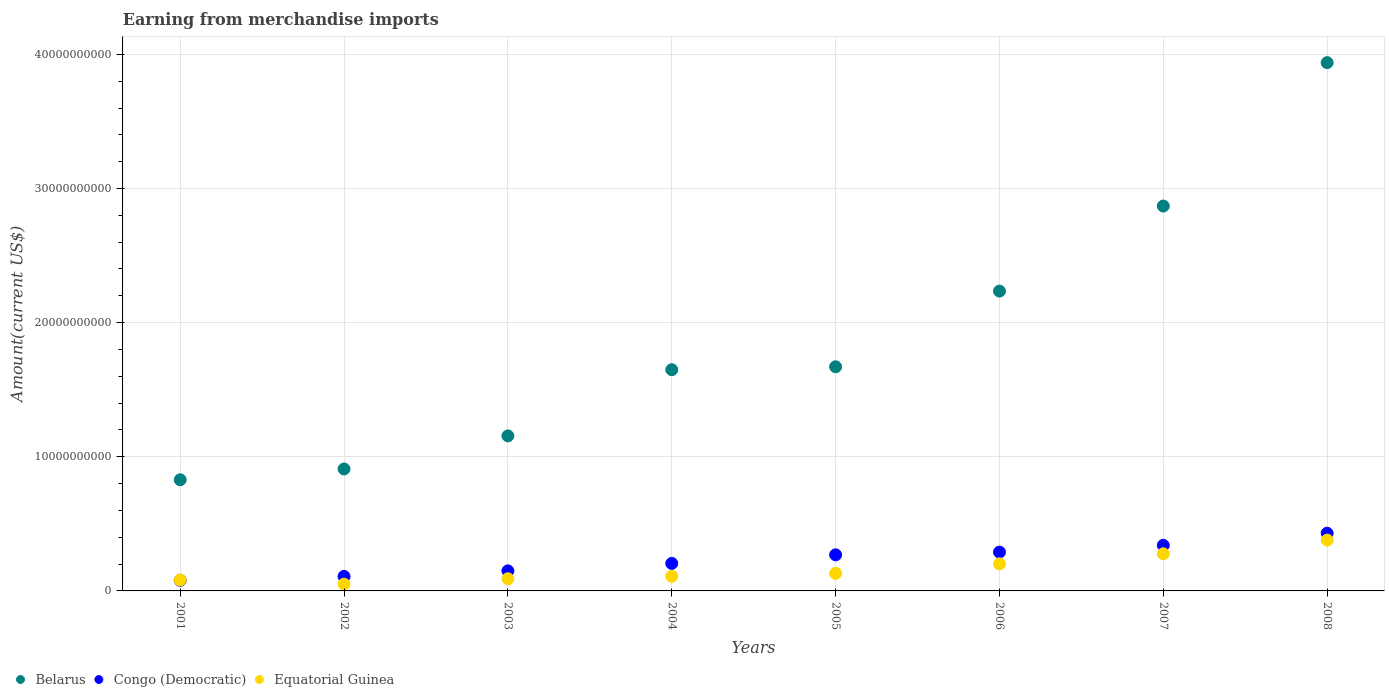What is the amount earned from merchandise imports in Congo (Democratic) in 2007?
Ensure brevity in your answer.  3.40e+09. Across all years, what is the maximum amount earned from merchandise imports in Equatorial Guinea?
Your answer should be compact. 3.79e+09. Across all years, what is the minimum amount earned from merchandise imports in Belarus?
Provide a short and direct response. 8.29e+09. In which year was the amount earned from merchandise imports in Equatorial Guinea minimum?
Your answer should be compact. 2002. What is the total amount earned from merchandise imports in Equatorial Guinea in the graph?
Provide a short and direct response. 1.32e+1. What is the difference between the amount earned from merchandise imports in Equatorial Guinea in 2001 and that in 2006?
Provide a short and direct response. -1.21e+09. What is the difference between the amount earned from merchandise imports in Congo (Democratic) in 2006 and the amount earned from merchandise imports in Equatorial Guinea in 2005?
Offer a very short reply. 1.58e+09. What is the average amount earned from merchandise imports in Belarus per year?
Your answer should be compact. 1.91e+1. In the year 2005, what is the difference between the amount earned from merchandise imports in Congo (Democratic) and amount earned from merchandise imports in Equatorial Guinea?
Provide a short and direct response. 1.38e+09. What is the ratio of the amount earned from merchandise imports in Belarus in 2001 to that in 2005?
Make the answer very short. 0.5. Is the difference between the amount earned from merchandise imports in Congo (Democratic) in 2004 and 2007 greater than the difference between the amount earned from merchandise imports in Equatorial Guinea in 2004 and 2007?
Make the answer very short. Yes. What is the difference between the highest and the second highest amount earned from merchandise imports in Belarus?
Ensure brevity in your answer.  1.07e+1. What is the difference between the highest and the lowest amount earned from merchandise imports in Congo (Democratic)?
Your answer should be very brief. 3.51e+09. In how many years, is the amount earned from merchandise imports in Congo (Democratic) greater than the average amount earned from merchandise imports in Congo (Democratic) taken over all years?
Provide a short and direct response. 4. Is the amount earned from merchandise imports in Belarus strictly less than the amount earned from merchandise imports in Equatorial Guinea over the years?
Give a very brief answer. No. What is the difference between two consecutive major ticks on the Y-axis?
Provide a short and direct response. 1.00e+1. Where does the legend appear in the graph?
Your response must be concise. Bottom left. How many legend labels are there?
Give a very brief answer. 3. How are the legend labels stacked?
Provide a succinct answer. Horizontal. What is the title of the graph?
Offer a terse response. Earning from merchandise imports. What is the label or title of the Y-axis?
Your response must be concise. Amount(current US$). What is the Amount(current US$) of Belarus in 2001?
Your response must be concise. 8.29e+09. What is the Amount(current US$) in Congo (Democratic) in 2001?
Your response must be concise. 7.90e+08. What is the Amount(current US$) of Equatorial Guinea in 2001?
Give a very brief answer. 8.13e+08. What is the Amount(current US$) in Belarus in 2002?
Provide a short and direct response. 9.09e+09. What is the Amount(current US$) of Congo (Democratic) in 2002?
Your answer should be very brief. 1.08e+09. What is the Amount(current US$) in Equatorial Guinea in 2002?
Give a very brief answer. 5.07e+08. What is the Amount(current US$) in Belarus in 2003?
Your answer should be compact. 1.16e+1. What is the Amount(current US$) of Congo (Democratic) in 2003?
Your response must be concise. 1.49e+09. What is the Amount(current US$) in Equatorial Guinea in 2003?
Provide a short and direct response. 9.08e+08. What is the Amount(current US$) of Belarus in 2004?
Ensure brevity in your answer.  1.65e+1. What is the Amount(current US$) of Congo (Democratic) in 2004?
Provide a succinct answer. 2.05e+09. What is the Amount(current US$) in Equatorial Guinea in 2004?
Ensure brevity in your answer.  1.09e+09. What is the Amount(current US$) of Belarus in 2005?
Offer a very short reply. 1.67e+1. What is the Amount(current US$) in Congo (Democratic) in 2005?
Your response must be concise. 2.69e+09. What is the Amount(current US$) in Equatorial Guinea in 2005?
Provide a short and direct response. 1.31e+09. What is the Amount(current US$) in Belarus in 2006?
Your response must be concise. 2.24e+1. What is the Amount(current US$) of Congo (Democratic) in 2006?
Provide a succinct answer. 2.89e+09. What is the Amount(current US$) in Equatorial Guinea in 2006?
Your answer should be compact. 2.02e+09. What is the Amount(current US$) of Belarus in 2007?
Provide a short and direct response. 2.87e+1. What is the Amount(current US$) in Congo (Democratic) in 2007?
Your answer should be very brief. 3.40e+09. What is the Amount(current US$) in Equatorial Guinea in 2007?
Offer a terse response. 2.77e+09. What is the Amount(current US$) of Belarus in 2008?
Provide a short and direct response. 3.94e+1. What is the Amount(current US$) of Congo (Democratic) in 2008?
Provide a succinct answer. 4.30e+09. What is the Amount(current US$) of Equatorial Guinea in 2008?
Ensure brevity in your answer.  3.79e+09. Across all years, what is the maximum Amount(current US$) of Belarus?
Make the answer very short. 3.94e+1. Across all years, what is the maximum Amount(current US$) in Congo (Democratic)?
Keep it short and to the point. 4.30e+09. Across all years, what is the maximum Amount(current US$) of Equatorial Guinea?
Your answer should be compact. 3.79e+09. Across all years, what is the minimum Amount(current US$) of Belarus?
Give a very brief answer. 8.29e+09. Across all years, what is the minimum Amount(current US$) in Congo (Democratic)?
Provide a succinct answer. 7.90e+08. Across all years, what is the minimum Amount(current US$) of Equatorial Guinea?
Give a very brief answer. 5.07e+08. What is the total Amount(current US$) of Belarus in the graph?
Your answer should be compact. 1.53e+11. What is the total Amount(current US$) of Congo (Democratic) in the graph?
Offer a very short reply. 1.87e+1. What is the total Amount(current US$) of Equatorial Guinea in the graph?
Offer a terse response. 1.32e+1. What is the difference between the Amount(current US$) of Belarus in 2001 and that in 2002?
Provide a succinct answer. -8.06e+08. What is the difference between the Amount(current US$) in Congo (Democratic) in 2001 and that in 2002?
Provide a succinct answer. -2.91e+08. What is the difference between the Amount(current US$) in Equatorial Guinea in 2001 and that in 2002?
Provide a short and direct response. 3.06e+08. What is the difference between the Amount(current US$) in Belarus in 2001 and that in 2003?
Make the answer very short. -3.27e+09. What is the difference between the Amount(current US$) in Congo (Democratic) in 2001 and that in 2003?
Provide a short and direct response. -7.05e+08. What is the difference between the Amount(current US$) of Equatorial Guinea in 2001 and that in 2003?
Provide a short and direct response. -9.50e+07. What is the difference between the Amount(current US$) of Belarus in 2001 and that in 2004?
Make the answer very short. -8.20e+09. What is the difference between the Amount(current US$) in Congo (Democratic) in 2001 and that in 2004?
Your response must be concise. -1.26e+09. What is the difference between the Amount(current US$) of Equatorial Guinea in 2001 and that in 2004?
Make the answer very short. -2.79e+08. What is the difference between the Amount(current US$) in Belarus in 2001 and that in 2005?
Offer a very short reply. -8.42e+09. What is the difference between the Amount(current US$) of Congo (Democratic) in 2001 and that in 2005?
Offer a very short reply. -1.90e+09. What is the difference between the Amount(current US$) in Equatorial Guinea in 2001 and that in 2005?
Provide a succinct answer. -4.97e+08. What is the difference between the Amount(current US$) in Belarus in 2001 and that in 2006?
Offer a very short reply. -1.41e+1. What is the difference between the Amount(current US$) in Congo (Democratic) in 2001 and that in 2006?
Your answer should be compact. -2.10e+09. What is the difference between the Amount(current US$) in Equatorial Guinea in 2001 and that in 2006?
Offer a very short reply. -1.21e+09. What is the difference between the Amount(current US$) of Belarus in 2001 and that in 2007?
Give a very brief answer. -2.04e+1. What is the difference between the Amount(current US$) in Congo (Democratic) in 2001 and that in 2007?
Provide a short and direct response. -2.61e+09. What is the difference between the Amount(current US$) in Equatorial Guinea in 2001 and that in 2007?
Offer a very short reply. -1.95e+09. What is the difference between the Amount(current US$) in Belarus in 2001 and that in 2008?
Keep it short and to the point. -3.11e+1. What is the difference between the Amount(current US$) in Congo (Democratic) in 2001 and that in 2008?
Your answer should be compact. -3.51e+09. What is the difference between the Amount(current US$) of Equatorial Guinea in 2001 and that in 2008?
Make the answer very short. -2.97e+09. What is the difference between the Amount(current US$) in Belarus in 2002 and that in 2003?
Provide a succinct answer. -2.47e+09. What is the difference between the Amount(current US$) in Congo (Democratic) in 2002 and that in 2003?
Provide a succinct answer. -4.14e+08. What is the difference between the Amount(current US$) in Equatorial Guinea in 2002 and that in 2003?
Make the answer very short. -4.01e+08. What is the difference between the Amount(current US$) in Belarus in 2002 and that in 2004?
Offer a very short reply. -7.40e+09. What is the difference between the Amount(current US$) in Congo (Democratic) in 2002 and that in 2004?
Ensure brevity in your answer.  -9.71e+08. What is the difference between the Amount(current US$) in Equatorial Guinea in 2002 and that in 2004?
Your answer should be very brief. -5.85e+08. What is the difference between the Amount(current US$) of Belarus in 2002 and that in 2005?
Your answer should be compact. -7.62e+09. What is the difference between the Amount(current US$) in Congo (Democratic) in 2002 and that in 2005?
Make the answer very short. -1.61e+09. What is the difference between the Amount(current US$) in Equatorial Guinea in 2002 and that in 2005?
Your answer should be compact. -8.03e+08. What is the difference between the Amount(current US$) in Belarus in 2002 and that in 2006?
Ensure brevity in your answer.  -1.33e+1. What is the difference between the Amount(current US$) of Congo (Democratic) in 2002 and that in 2006?
Your response must be concise. -1.81e+09. What is the difference between the Amount(current US$) of Equatorial Guinea in 2002 and that in 2006?
Your response must be concise. -1.51e+09. What is the difference between the Amount(current US$) in Belarus in 2002 and that in 2007?
Ensure brevity in your answer.  -1.96e+1. What is the difference between the Amount(current US$) of Congo (Democratic) in 2002 and that in 2007?
Make the answer very short. -2.32e+09. What is the difference between the Amount(current US$) in Equatorial Guinea in 2002 and that in 2007?
Give a very brief answer. -2.26e+09. What is the difference between the Amount(current US$) of Belarus in 2002 and that in 2008?
Your answer should be very brief. -3.03e+1. What is the difference between the Amount(current US$) of Congo (Democratic) in 2002 and that in 2008?
Ensure brevity in your answer.  -3.22e+09. What is the difference between the Amount(current US$) in Equatorial Guinea in 2002 and that in 2008?
Your answer should be very brief. -3.28e+09. What is the difference between the Amount(current US$) of Belarus in 2003 and that in 2004?
Offer a very short reply. -4.93e+09. What is the difference between the Amount(current US$) in Congo (Democratic) in 2003 and that in 2004?
Make the answer very short. -5.57e+08. What is the difference between the Amount(current US$) in Equatorial Guinea in 2003 and that in 2004?
Give a very brief answer. -1.84e+08. What is the difference between the Amount(current US$) of Belarus in 2003 and that in 2005?
Make the answer very short. -5.15e+09. What is the difference between the Amount(current US$) in Congo (Democratic) in 2003 and that in 2005?
Give a very brief answer. -1.20e+09. What is the difference between the Amount(current US$) in Equatorial Guinea in 2003 and that in 2005?
Ensure brevity in your answer.  -4.02e+08. What is the difference between the Amount(current US$) of Belarus in 2003 and that in 2006?
Offer a terse response. -1.08e+1. What is the difference between the Amount(current US$) of Congo (Democratic) in 2003 and that in 2006?
Make the answer very short. -1.40e+09. What is the difference between the Amount(current US$) in Equatorial Guinea in 2003 and that in 2006?
Offer a very short reply. -1.11e+09. What is the difference between the Amount(current US$) of Belarus in 2003 and that in 2007?
Keep it short and to the point. -1.71e+1. What is the difference between the Amount(current US$) of Congo (Democratic) in 2003 and that in 2007?
Your answer should be compact. -1.91e+09. What is the difference between the Amount(current US$) in Equatorial Guinea in 2003 and that in 2007?
Make the answer very short. -1.86e+09. What is the difference between the Amount(current US$) of Belarus in 2003 and that in 2008?
Your answer should be very brief. -2.78e+1. What is the difference between the Amount(current US$) in Congo (Democratic) in 2003 and that in 2008?
Ensure brevity in your answer.  -2.81e+09. What is the difference between the Amount(current US$) in Equatorial Guinea in 2003 and that in 2008?
Your response must be concise. -2.88e+09. What is the difference between the Amount(current US$) of Belarus in 2004 and that in 2005?
Make the answer very short. -2.17e+08. What is the difference between the Amount(current US$) of Congo (Democratic) in 2004 and that in 2005?
Your answer should be very brief. -6.39e+08. What is the difference between the Amount(current US$) in Equatorial Guinea in 2004 and that in 2005?
Your answer should be compact. -2.18e+08. What is the difference between the Amount(current US$) in Belarus in 2004 and that in 2006?
Provide a short and direct response. -5.86e+09. What is the difference between the Amount(current US$) of Congo (Democratic) in 2004 and that in 2006?
Keep it short and to the point. -8.40e+08. What is the difference between the Amount(current US$) in Equatorial Guinea in 2004 and that in 2006?
Provide a short and direct response. -9.28e+08. What is the difference between the Amount(current US$) of Belarus in 2004 and that in 2007?
Make the answer very short. -1.22e+1. What is the difference between the Amount(current US$) in Congo (Democratic) in 2004 and that in 2007?
Keep it short and to the point. -1.35e+09. What is the difference between the Amount(current US$) of Equatorial Guinea in 2004 and that in 2007?
Your response must be concise. -1.68e+09. What is the difference between the Amount(current US$) of Belarus in 2004 and that in 2008?
Keep it short and to the point. -2.29e+1. What is the difference between the Amount(current US$) of Congo (Democratic) in 2004 and that in 2008?
Provide a short and direct response. -2.25e+09. What is the difference between the Amount(current US$) in Equatorial Guinea in 2004 and that in 2008?
Make the answer very short. -2.69e+09. What is the difference between the Amount(current US$) in Belarus in 2005 and that in 2006?
Provide a short and direct response. -5.64e+09. What is the difference between the Amount(current US$) of Congo (Democratic) in 2005 and that in 2006?
Your response must be concise. -2.01e+08. What is the difference between the Amount(current US$) in Equatorial Guinea in 2005 and that in 2006?
Your answer should be very brief. -7.10e+08. What is the difference between the Amount(current US$) in Belarus in 2005 and that in 2007?
Give a very brief answer. -1.20e+1. What is the difference between the Amount(current US$) of Congo (Democratic) in 2005 and that in 2007?
Keep it short and to the point. -7.10e+08. What is the difference between the Amount(current US$) of Equatorial Guinea in 2005 and that in 2007?
Your response must be concise. -1.46e+09. What is the difference between the Amount(current US$) of Belarus in 2005 and that in 2008?
Offer a terse response. -2.27e+1. What is the difference between the Amount(current US$) of Congo (Democratic) in 2005 and that in 2008?
Keep it short and to the point. -1.61e+09. What is the difference between the Amount(current US$) of Equatorial Guinea in 2005 and that in 2008?
Offer a very short reply. -2.48e+09. What is the difference between the Amount(current US$) in Belarus in 2006 and that in 2007?
Provide a succinct answer. -6.34e+09. What is the difference between the Amount(current US$) of Congo (Democratic) in 2006 and that in 2007?
Provide a short and direct response. -5.08e+08. What is the difference between the Amount(current US$) in Equatorial Guinea in 2006 and that in 2007?
Provide a short and direct response. -7.47e+08. What is the difference between the Amount(current US$) in Belarus in 2006 and that in 2008?
Offer a very short reply. -1.70e+1. What is the difference between the Amount(current US$) of Congo (Democratic) in 2006 and that in 2008?
Give a very brief answer. -1.41e+09. What is the difference between the Amount(current US$) in Equatorial Guinea in 2006 and that in 2008?
Provide a succinct answer. -1.77e+09. What is the difference between the Amount(current US$) in Belarus in 2007 and that in 2008?
Provide a short and direct response. -1.07e+1. What is the difference between the Amount(current US$) in Congo (Democratic) in 2007 and that in 2008?
Provide a short and direct response. -9.00e+08. What is the difference between the Amount(current US$) in Equatorial Guinea in 2007 and that in 2008?
Your answer should be compact. -1.02e+09. What is the difference between the Amount(current US$) of Belarus in 2001 and the Amount(current US$) of Congo (Democratic) in 2002?
Your answer should be very brief. 7.21e+09. What is the difference between the Amount(current US$) in Belarus in 2001 and the Amount(current US$) in Equatorial Guinea in 2002?
Ensure brevity in your answer.  7.78e+09. What is the difference between the Amount(current US$) in Congo (Democratic) in 2001 and the Amount(current US$) in Equatorial Guinea in 2002?
Your response must be concise. 2.82e+08. What is the difference between the Amount(current US$) in Belarus in 2001 and the Amount(current US$) in Congo (Democratic) in 2003?
Make the answer very short. 6.79e+09. What is the difference between the Amount(current US$) of Belarus in 2001 and the Amount(current US$) of Equatorial Guinea in 2003?
Your response must be concise. 7.38e+09. What is the difference between the Amount(current US$) in Congo (Democratic) in 2001 and the Amount(current US$) in Equatorial Guinea in 2003?
Offer a very short reply. -1.18e+08. What is the difference between the Amount(current US$) in Belarus in 2001 and the Amount(current US$) in Congo (Democratic) in 2004?
Offer a terse response. 6.23e+09. What is the difference between the Amount(current US$) in Belarus in 2001 and the Amount(current US$) in Equatorial Guinea in 2004?
Ensure brevity in your answer.  7.19e+09. What is the difference between the Amount(current US$) in Congo (Democratic) in 2001 and the Amount(current US$) in Equatorial Guinea in 2004?
Your answer should be very brief. -3.02e+08. What is the difference between the Amount(current US$) of Belarus in 2001 and the Amount(current US$) of Congo (Democratic) in 2005?
Offer a very short reply. 5.60e+09. What is the difference between the Amount(current US$) in Belarus in 2001 and the Amount(current US$) in Equatorial Guinea in 2005?
Your response must be concise. 6.98e+09. What is the difference between the Amount(current US$) of Congo (Democratic) in 2001 and the Amount(current US$) of Equatorial Guinea in 2005?
Provide a succinct answer. -5.20e+08. What is the difference between the Amount(current US$) in Belarus in 2001 and the Amount(current US$) in Congo (Democratic) in 2006?
Provide a succinct answer. 5.39e+09. What is the difference between the Amount(current US$) of Belarus in 2001 and the Amount(current US$) of Equatorial Guinea in 2006?
Offer a very short reply. 6.27e+09. What is the difference between the Amount(current US$) of Congo (Democratic) in 2001 and the Amount(current US$) of Equatorial Guinea in 2006?
Provide a short and direct response. -1.23e+09. What is the difference between the Amount(current US$) of Belarus in 2001 and the Amount(current US$) of Congo (Democratic) in 2007?
Make the answer very short. 4.89e+09. What is the difference between the Amount(current US$) of Belarus in 2001 and the Amount(current US$) of Equatorial Guinea in 2007?
Your answer should be very brief. 5.52e+09. What is the difference between the Amount(current US$) in Congo (Democratic) in 2001 and the Amount(current US$) in Equatorial Guinea in 2007?
Your answer should be very brief. -1.98e+09. What is the difference between the Amount(current US$) of Belarus in 2001 and the Amount(current US$) of Congo (Democratic) in 2008?
Offer a terse response. 3.99e+09. What is the difference between the Amount(current US$) of Belarus in 2001 and the Amount(current US$) of Equatorial Guinea in 2008?
Provide a short and direct response. 4.50e+09. What is the difference between the Amount(current US$) of Congo (Democratic) in 2001 and the Amount(current US$) of Equatorial Guinea in 2008?
Ensure brevity in your answer.  -3.00e+09. What is the difference between the Amount(current US$) of Belarus in 2002 and the Amount(current US$) of Congo (Democratic) in 2003?
Your answer should be compact. 7.60e+09. What is the difference between the Amount(current US$) in Belarus in 2002 and the Amount(current US$) in Equatorial Guinea in 2003?
Provide a succinct answer. 8.18e+09. What is the difference between the Amount(current US$) of Congo (Democratic) in 2002 and the Amount(current US$) of Equatorial Guinea in 2003?
Offer a terse response. 1.72e+08. What is the difference between the Amount(current US$) in Belarus in 2002 and the Amount(current US$) in Congo (Democratic) in 2004?
Give a very brief answer. 7.04e+09. What is the difference between the Amount(current US$) of Belarus in 2002 and the Amount(current US$) of Equatorial Guinea in 2004?
Your answer should be compact. 8.00e+09. What is the difference between the Amount(current US$) in Congo (Democratic) in 2002 and the Amount(current US$) in Equatorial Guinea in 2004?
Provide a succinct answer. -1.15e+07. What is the difference between the Amount(current US$) in Belarus in 2002 and the Amount(current US$) in Congo (Democratic) in 2005?
Offer a terse response. 6.40e+09. What is the difference between the Amount(current US$) in Belarus in 2002 and the Amount(current US$) in Equatorial Guinea in 2005?
Make the answer very short. 7.78e+09. What is the difference between the Amount(current US$) of Congo (Democratic) in 2002 and the Amount(current US$) of Equatorial Guinea in 2005?
Make the answer very short. -2.30e+08. What is the difference between the Amount(current US$) in Belarus in 2002 and the Amount(current US$) in Congo (Democratic) in 2006?
Your response must be concise. 6.20e+09. What is the difference between the Amount(current US$) of Belarus in 2002 and the Amount(current US$) of Equatorial Guinea in 2006?
Offer a terse response. 7.07e+09. What is the difference between the Amount(current US$) in Congo (Democratic) in 2002 and the Amount(current US$) in Equatorial Guinea in 2006?
Your response must be concise. -9.40e+08. What is the difference between the Amount(current US$) of Belarus in 2002 and the Amount(current US$) of Congo (Democratic) in 2007?
Ensure brevity in your answer.  5.69e+09. What is the difference between the Amount(current US$) in Belarus in 2002 and the Amount(current US$) in Equatorial Guinea in 2007?
Keep it short and to the point. 6.32e+09. What is the difference between the Amount(current US$) in Congo (Democratic) in 2002 and the Amount(current US$) in Equatorial Guinea in 2007?
Offer a very short reply. -1.69e+09. What is the difference between the Amount(current US$) in Belarus in 2002 and the Amount(current US$) in Congo (Democratic) in 2008?
Your response must be concise. 4.79e+09. What is the difference between the Amount(current US$) of Belarus in 2002 and the Amount(current US$) of Equatorial Guinea in 2008?
Make the answer very short. 5.31e+09. What is the difference between the Amount(current US$) of Congo (Democratic) in 2002 and the Amount(current US$) of Equatorial Guinea in 2008?
Give a very brief answer. -2.71e+09. What is the difference between the Amount(current US$) in Belarus in 2003 and the Amount(current US$) in Congo (Democratic) in 2004?
Make the answer very short. 9.51e+09. What is the difference between the Amount(current US$) of Belarus in 2003 and the Amount(current US$) of Equatorial Guinea in 2004?
Provide a succinct answer. 1.05e+1. What is the difference between the Amount(current US$) of Congo (Democratic) in 2003 and the Amount(current US$) of Equatorial Guinea in 2004?
Give a very brief answer. 4.03e+08. What is the difference between the Amount(current US$) of Belarus in 2003 and the Amount(current US$) of Congo (Democratic) in 2005?
Provide a succinct answer. 8.87e+09. What is the difference between the Amount(current US$) in Belarus in 2003 and the Amount(current US$) in Equatorial Guinea in 2005?
Provide a short and direct response. 1.02e+1. What is the difference between the Amount(current US$) of Congo (Democratic) in 2003 and the Amount(current US$) of Equatorial Guinea in 2005?
Your answer should be very brief. 1.85e+08. What is the difference between the Amount(current US$) of Belarus in 2003 and the Amount(current US$) of Congo (Democratic) in 2006?
Keep it short and to the point. 8.67e+09. What is the difference between the Amount(current US$) of Belarus in 2003 and the Amount(current US$) of Equatorial Guinea in 2006?
Your response must be concise. 9.54e+09. What is the difference between the Amount(current US$) of Congo (Democratic) in 2003 and the Amount(current US$) of Equatorial Guinea in 2006?
Your answer should be compact. -5.25e+08. What is the difference between the Amount(current US$) of Belarus in 2003 and the Amount(current US$) of Congo (Democratic) in 2007?
Your response must be concise. 8.16e+09. What is the difference between the Amount(current US$) in Belarus in 2003 and the Amount(current US$) in Equatorial Guinea in 2007?
Make the answer very short. 8.79e+09. What is the difference between the Amount(current US$) in Congo (Democratic) in 2003 and the Amount(current US$) in Equatorial Guinea in 2007?
Your response must be concise. -1.27e+09. What is the difference between the Amount(current US$) of Belarus in 2003 and the Amount(current US$) of Congo (Democratic) in 2008?
Your answer should be very brief. 7.26e+09. What is the difference between the Amount(current US$) in Belarus in 2003 and the Amount(current US$) in Equatorial Guinea in 2008?
Make the answer very short. 7.77e+09. What is the difference between the Amount(current US$) in Congo (Democratic) in 2003 and the Amount(current US$) in Equatorial Guinea in 2008?
Offer a terse response. -2.29e+09. What is the difference between the Amount(current US$) of Belarus in 2004 and the Amount(current US$) of Congo (Democratic) in 2005?
Make the answer very short. 1.38e+1. What is the difference between the Amount(current US$) in Belarus in 2004 and the Amount(current US$) in Equatorial Guinea in 2005?
Keep it short and to the point. 1.52e+1. What is the difference between the Amount(current US$) of Congo (Democratic) in 2004 and the Amount(current US$) of Equatorial Guinea in 2005?
Provide a succinct answer. 7.41e+08. What is the difference between the Amount(current US$) of Belarus in 2004 and the Amount(current US$) of Congo (Democratic) in 2006?
Offer a very short reply. 1.36e+1. What is the difference between the Amount(current US$) in Belarus in 2004 and the Amount(current US$) in Equatorial Guinea in 2006?
Keep it short and to the point. 1.45e+1. What is the difference between the Amount(current US$) in Congo (Democratic) in 2004 and the Amount(current US$) in Equatorial Guinea in 2006?
Ensure brevity in your answer.  3.14e+07. What is the difference between the Amount(current US$) of Belarus in 2004 and the Amount(current US$) of Congo (Democratic) in 2007?
Provide a succinct answer. 1.31e+1. What is the difference between the Amount(current US$) of Belarus in 2004 and the Amount(current US$) of Equatorial Guinea in 2007?
Your response must be concise. 1.37e+1. What is the difference between the Amount(current US$) in Congo (Democratic) in 2004 and the Amount(current US$) in Equatorial Guinea in 2007?
Make the answer very short. -7.16e+08. What is the difference between the Amount(current US$) of Belarus in 2004 and the Amount(current US$) of Congo (Democratic) in 2008?
Your response must be concise. 1.22e+1. What is the difference between the Amount(current US$) in Belarus in 2004 and the Amount(current US$) in Equatorial Guinea in 2008?
Offer a terse response. 1.27e+1. What is the difference between the Amount(current US$) in Congo (Democratic) in 2004 and the Amount(current US$) in Equatorial Guinea in 2008?
Your response must be concise. -1.74e+09. What is the difference between the Amount(current US$) of Belarus in 2005 and the Amount(current US$) of Congo (Democratic) in 2006?
Provide a succinct answer. 1.38e+1. What is the difference between the Amount(current US$) of Belarus in 2005 and the Amount(current US$) of Equatorial Guinea in 2006?
Give a very brief answer. 1.47e+1. What is the difference between the Amount(current US$) of Congo (Democratic) in 2005 and the Amount(current US$) of Equatorial Guinea in 2006?
Your response must be concise. 6.70e+08. What is the difference between the Amount(current US$) in Belarus in 2005 and the Amount(current US$) in Congo (Democratic) in 2007?
Provide a succinct answer. 1.33e+1. What is the difference between the Amount(current US$) in Belarus in 2005 and the Amount(current US$) in Equatorial Guinea in 2007?
Provide a short and direct response. 1.39e+1. What is the difference between the Amount(current US$) of Congo (Democratic) in 2005 and the Amount(current US$) of Equatorial Guinea in 2007?
Keep it short and to the point. -7.70e+07. What is the difference between the Amount(current US$) of Belarus in 2005 and the Amount(current US$) of Congo (Democratic) in 2008?
Offer a very short reply. 1.24e+1. What is the difference between the Amount(current US$) in Belarus in 2005 and the Amount(current US$) in Equatorial Guinea in 2008?
Your answer should be very brief. 1.29e+1. What is the difference between the Amount(current US$) in Congo (Democratic) in 2005 and the Amount(current US$) in Equatorial Guinea in 2008?
Your answer should be very brief. -1.10e+09. What is the difference between the Amount(current US$) in Belarus in 2006 and the Amount(current US$) in Congo (Democratic) in 2007?
Offer a very short reply. 1.90e+1. What is the difference between the Amount(current US$) in Belarus in 2006 and the Amount(current US$) in Equatorial Guinea in 2007?
Your answer should be compact. 1.96e+1. What is the difference between the Amount(current US$) of Congo (Democratic) in 2006 and the Amount(current US$) of Equatorial Guinea in 2007?
Provide a succinct answer. 1.24e+08. What is the difference between the Amount(current US$) of Belarus in 2006 and the Amount(current US$) of Congo (Democratic) in 2008?
Provide a short and direct response. 1.81e+1. What is the difference between the Amount(current US$) in Belarus in 2006 and the Amount(current US$) in Equatorial Guinea in 2008?
Your answer should be very brief. 1.86e+1. What is the difference between the Amount(current US$) of Congo (Democratic) in 2006 and the Amount(current US$) of Equatorial Guinea in 2008?
Provide a succinct answer. -8.95e+08. What is the difference between the Amount(current US$) of Belarus in 2007 and the Amount(current US$) of Congo (Democratic) in 2008?
Provide a short and direct response. 2.44e+1. What is the difference between the Amount(current US$) of Belarus in 2007 and the Amount(current US$) of Equatorial Guinea in 2008?
Your response must be concise. 2.49e+1. What is the difference between the Amount(current US$) of Congo (Democratic) in 2007 and the Amount(current US$) of Equatorial Guinea in 2008?
Offer a terse response. -3.87e+08. What is the average Amount(current US$) of Belarus per year?
Make the answer very short. 1.91e+1. What is the average Amount(current US$) of Congo (Democratic) per year?
Keep it short and to the point. 2.34e+09. What is the average Amount(current US$) of Equatorial Guinea per year?
Your answer should be compact. 1.65e+09. In the year 2001, what is the difference between the Amount(current US$) of Belarus and Amount(current US$) of Congo (Democratic)?
Make the answer very short. 7.50e+09. In the year 2001, what is the difference between the Amount(current US$) in Belarus and Amount(current US$) in Equatorial Guinea?
Give a very brief answer. 7.47e+09. In the year 2001, what is the difference between the Amount(current US$) of Congo (Democratic) and Amount(current US$) of Equatorial Guinea?
Your response must be concise. -2.35e+07. In the year 2002, what is the difference between the Amount(current US$) in Belarus and Amount(current US$) in Congo (Democratic)?
Your answer should be compact. 8.01e+09. In the year 2002, what is the difference between the Amount(current US$) in Belarus and Amount(current US$) in Equatorial Guinea?
Provide a succinct answer. 8.59e+09. In the year 2002, what is the difference between the Amount(current US$) in Congo (Democratic) and Amount(current US$) in Equatorial Guinea?
Ensure brevity in your answer.  5.74e+08. In the year 2003, what is the difference between the Amount(current US$) of Belarus and Amount(current US$) of Congo (Democratic)?
Your response must be concise. 1.01e+1. In the year 2003, what is the difference between the Amount(current US$) in Belarus and Amount(current US$) in Equatorial Guinea?
Provide a short and direct response. 1.06e+1. In the year 2003, what is the difference between the Amount(current US$) of Congo (Democratic) and Amount(current US$) of Equatorial Guinea?
Give a very brief answer. 5.87e+08. In the year 2004, what is the difference between the Amount(current US$) of Belarus and Amount(current US$) of Congo (Democratic)?
Keep it short and to the point. 1.44e+1. In the year 2004, what is the difference between the Amount(current US$) of Belarus and Amount(current US$) of Equatorial Guinea?
Offer a terse response. 1.54e+1. In the year 2004, what is the difference between the Amount(current US$) in Congo (Democratic) and Amount(current US$) in Equatorial Guinea?
Give a very brief answer. 9.59e+08. In the year 2005, what is the difference between the Amount(current US$) of Belarus and Amount(current US$) of Congo (Democratic)?
Make the answer very short. 1.40e+1. In the year 2005, what is the difference between the Amount(current US$) in Belarus and Amount(current US$) in Equatorial Guinea?
Provide a short and direct response. 1.54e+1. In the year 2005, what is the difference between the Amount(current US$) of Congo (Democratic) and Amount(current US$) of Equatorial Guinea?
Your answer should be very brief. 1.38e+09. In the year 2006, what is the difference between the Amount(current US$) in Belarus and Amount(current US$) in Congo (Democratic)?
Provide a short and direct response. 1.95e+1. In the year 2006, what is the difference between the Amount(current US$) in Belarus and Amount(current US$) in Equatorial Guinea?
Make the answer very short. 2.03e+1. In the year 2006, what is the difference between the Amount(current US$) of Congo (Democratic) and Amount(current US$) of Equatorial Guinea?
Ensure brevity in your answer.  8.72e+08. In the year 2007, what is the difference between the Amount(current US$) of Belarus and Amount(current US$) of Congo (Democratic)?
Make the answer very short. 2.53e+1. In the year 2007, what is the difference between the Amount(current US$) of Belarus and Amount(current US$) of Equatorial Guinea?
Your answer should be very brief. 2.59e+1. In the year 2007, what is the difference between the Amount(current US$) in Congo (Democratic) and Amount(current US$) in Equatorial Guinea?
Your response must be concise. 6.33e+08. In the year 2008, what is the difference between the Amount(current US$) in Belarus and Amount(current US$) in Congo (Democratic)?
Provide a succinct answer. 3.51e+1. In the year 2008, what is the difference between the Amount(current US$) in Belarus and Amount(current US$) in Equatorial Guinea?
Make the answer very short. 3.56e+1. In the year 2008, what is the difference between the Amount(current US$) in Congo (Democratic) and Amount(current US$) in Equatorial Guinea?
Offer a very short reply. 5.13e+08. What is the ratio of the Amount(current US$) in Belarus in 2001 to that in 2002?
Your answer should be very brief. 0.91. What is the ratio of the Amount(current US$) in Congo (Democratic) in 2001 to that in 2002?
Provide a succinct answer. 0.73. What is the ratio of the Amount(current US$) of Equatorial Guinea in 2001 to that in 2002?
Your answer should be compact. 1.6. What is the ratio of the Amount(current US$) in Belarus in 2001 to that in 2003?
Make the answer very short. 0.72. What is the ratio of the Amount(current US$) of Congo (Democratic) in 2001 to that in 2003?
Make the answer very short. 0.53. What is the ratio of the Amount(current US$) of Equatorial Guinea in 2001 to that in 2003?
Offer a terse response. 0.9. What is the ratio of the Amount(current US$) in Belarus in 2001 to that in 2004?
Your response must be concise. 0.5. What is the ratio of the Amount(current US$) in Congo (Democratic) in 2001 to that in 2004?
Keep it short and to the point. 0.38. What is the ratio of the Amount(current US$) of Equatorial Guinea in 2001 to that in 2004?
Make the answer very short. 0.74. What is the ratio of the Amount(current US$) of Belarus in 2001 to that in 2005?
Give a very brief answer. 0.5. What is the ratio of the Amount(current US$) in Congo (Democratic) in 2001 to that in 2005?
Offer a very short reply. 0.29. What is the ratio of the Amount(current US$) in Equatorial Guinea in 2001 to that in 2005?
Provide a short and direct response. 0.62. What is the ratio of the Amount(current US$) in Belarus in 2001 to that in 2006?
Make the answer very short. 0.37. What is the ratio of the Amount(current US$) in Congo (Democratic) in 2001 to that in 2006?
Provide a succinct answer. 0.27. What is the ratio of the Amount(current US$) of Equatorial Guinea in 2001 to that in 2006?
Your answer should be compact. 0.4. What is the ratio of the Amount(current US$) in Belarus in 2001 to that in 2007?
Offer a terse response. 0.29. What is the ratio of the Amount(current US$) in Congo (Democratic) in 2001 to that in 2007?
Make the answer very short. 0.23. What is the ratio of the Amount(current US$) in Equatorial Guinea in 2001 to that in 2007?
Ensure brevity in your answer.  0.29. What is the ratio of the Amount(current US$) of Belarus in 2001 to that in 2008?
Give a very brief answer. 0.21. What is the ratio of the Amount(current US$) of Congo (Democratic) in 2001 to that in 2008?
Make the answer very short. 0.18. What is the ratio of the Amount(current US$) of Equatorial Guinea in 2001 to that in 2008?
Ensure brevity in your answer.  0.21. What is the ratio of the Amount(current US$) in Belarus in 2002 to that in 2003?
Offer a very short reply. 0.79. What is the ratio of the Amount(current US$) of Congo (Democratic) in 2002 to that in 2003?
Your answer should be very brief. 0.72. What is the ratio of the Amount(current US$) of Equatorial Guinea in 2002 to that in 2003?
Your answer should be compact. 0.56. What is the ratio of the Amount(current US$) in Belarus in 2002 to that in 2004?
Keep it short and to the point. 0.55. What is the ratio of the Amount(current US$) of Congo (Democratic) in 2002 to that in 2004?
Your answer should be compact. 0.53. What is the ratio of the Amount(current US$) of Equatorial Guinea in 2002 to that in 2004?
Your answer should be compact. 0.46. What is the ratio of the Amount(current US$) in Belarus in 2002 to that in 2005?
Your answer should be very brief. 0.54. What is the ratio of the Amount(current US$) of Congo (Democratic) in 2002 to that in 2005?
Your answer should be compact. 0.4. What is the ratio of the Amount(current US$) of Equatorial Guinea in 2002 to that in 2005?
Offer a terse response. 0.39. What is the ratio of the Amount(current US$) in Belarus in 2002 to that in 2006?
Your answer should be very brief. 0.41. What is the ratio of the Amount(current US$) in Congo (Democratic) in 2002 to that in 2006?
Your response must be concise. 0.37. What is the ratio of the Amount(current US$) of Equatorial Guinea in 2002 to that in 2006?
Your answer should be very brief. 0.25. What is the ratio of the Amount(current US$) in Belarus in 2002 to that in 2007?
Provide a succinct answer. 0.32. What is the ratio of the Amount(current US$) in Congo (Democratic) in 2002 to that in 2007?
Your answer should be compact. 0.32. What is the ratio of the Amount(current US$) of Equatorial Guinea in 2002 to that in 2007?
Provide a succinct answer. 0.18. What is the ratio of the Amount(current US$) in Belarus in 2002 to that in 2008?
Your answer should be compact. 0.23. What is the ratio of the Amount(current US$) of Congo (Democratic) in 2002 to that in 2008?
Ensure brevity in your answer.  0.25. What is the ratio of the Amount(current US$) in Equatorial Guinea in 2002 to that in 2008?
Your answer should be compact. 0.13. What is the ratio of the Amount(current US$) of Belarus in 2003 to that in 2004?
Keep it short and to the point. 0.7. What is the ratio of the Amount(current US$) of Congo (Democratic) in 2003 to that in 2004?
Provide a short and direct response. 0.73. What is the ratio of the Amount(current US$) of Equatorial Guinea in 2003 to that in 2004?
Keep it short and to the point. 0.83. What is the ratio of the Amount(current US$) in Belarus in 2003 to that in 2005?
Provide a short and direct response. 0.69. What is the ratio of the Amount(current US$) in Congo (Democratic) in 2003 to that in 2005?
Your response must be concise. 0.56. What is the ratio of the Amount(current US$) of Equatorial Guinea in 2003 to that in 2005?
Provide a short and direct response. 0.69. What is the ratio of the Amount(current US$) in Belarus in 2003 to that in 2006?
Make the answer very short. 0.52. What is the ratio of the Amount(current US$) in Congo (Democratic) in 2003 to that in 2006?
Make the answer very short. 0.52. What is the ratio of the Amount(current US$) of Equatorial Guinea in 2003 to that in 2006?
Keep it short and to the point. 0.45. What is the ratio of the Amount(current US$) in Belarus in 2003 to that in 2007?
Give a very brief answer. 0.4. What is the ratio of the Amount(current US$) of Congo (Democratic) in 2003 to that in 2007?
Your answer should be compact. 0.44. What is the ratio of the Amount(current US$) of Equatorial Guinea in 2003 to that in 2007?
Ensure brevity in your answer.  0.33. What is the ratio of the Amount(current US$) in Belarus in 2003 to that in 2008?
Your answer should be compact. 0.29. What is the ratio of the Amount(current US$) of Congo (Democratic) in 2003 to that in 2008?
Offer a very short reply. 0.35. What is the ratio of the Amount(current US$) of Equatorial Guinea in 2003 to that in 2008?
Make the answer very short. 0.24. What is the ratio of the Amount(current US$) of Belarus in 2004 to that in 2005?
Your answer should be compact. 0.99. What is the ratio of the Amount(current US$) in Congo (Democratic) in 2004 to that in 2005?
Give a very brief answer. 0.76. What is the ratio of the Amount(current US$) in Equatorial Guinea in 2004 to that in 2005?
Offer a terse response. 0.83. What is the ratio of the Amount(current US$) of Belarus in 2004 to that in 2006?
Make the answer very short. 0.74. What is the ratio of the Amount(current US$) in Congo (Democratic) in 2004 to that in 2006?
Ensure brevity in your answer.  0.71. What is the ratio of the Amount(current US$) in Equatorial Guinea in 2004 to that in 2006?
Your response must be concise. 0.54. What is the ratio of the Amount(current US$) of Belarus in 2004 to that in 2007?
Make the answer very short. 0.57. What is the ratio of the Amount(current US$) of Congo (Democratic) in 2004 to that in 2007?
Give a very brief answer. 0.6. What is the ratio of the Amount(current US$) of Equatorial Guinea in 2004 to that in 2007?
Your answer should be compact. 0.39. What is the ratio of the Amount(current US$) in Belarus in 2004 to that in 2008?
Keep it short and to the point. 0.42. What is the ratio of the Amount(current US$) in Congo (Democratic) in 2004 to that in 2008?
Your answer should be compact. 0.48. What is the ratio of the Amount(current US$) in Equatorial Guinea in 2004 to that in 2008?
Your answer should be compact. 0.29. What is the ratio of the Amount(current US$) in Belarus in 2005 to that in 2006?
Offer a terse response. 0.75. What is the ratio of the Amount(current US$) in Congo (Democratic) in 2005 to that in 2006?
Offer a terse response. 0.93. What is the ratio of the Amount(current US$) in Equatorial Guinea in 2005 to that in 2006?
Your answer should be compact. 0.65. What is the ratio of the Amount(current US$) in Belarus in 2005 to that in 2007?
Offer a very short reply. 0.58. What is the ratio of the Amount(current US$) of Congo (Democratic) in 2005 to that in 2007?
Offer a terse response. 0.79. What is the ratio of the Amount(current US$) of Equatorial Guinea in 2005 to that in 2007?
Offer a terse response. 0.47. What is the ratio of the Amount(current US$) in Belarus in 2005 to that in 2008?
Keep it short and to the point. 0.42. What is the ratio of the Amount(current US$) of Congo (Democratic) in 2005 to that in 2008?
Provide a short and direct response. 0.63. What is the ratio of the Amount(current US$) in Equatorial Guinea in 2005 to that in 2008?
Ensure brevity in your answer.  0.35. What is the ratio of the Amount(current US$) of Belarus in 2006 to that in 2007?
Provide a short and direct response. 0.78. What is the ratio of the Amount(current US$) of Congo (Democratic) in 2006 to that in 2007?
Provide a succinct answer. 0.85. What is the ratio of the Amount(current US$) in Equatorial Guinea in 2006 to that in 2007?
Your answer should be compact. 0.73. What is the ratio of the Amount(current US$) in Belarus in 2006 to that in 2008?
Provide a short and direct response. 0.57. What is the ratio of the Amount(current US$) of Congo (Democratic) in 2006 to that in 2008?
Your response must be concise. 0.67. What is the ratio of the Amount(current US$) of Equatorial Guinea in 2006 to that in 2008?
Make the answer very short. 0.53. What is the ratio of the Amount(current US$) in Belarus in 2007 to that in 2008?
Offer a very short reply. 0.73. What is the ratio of the Amount(current US$) in Congo (Democratic) in 2007 to that in 2008?
Ensure brevity in your answer.  0.79. What is the ratio of the Amount(current US$) in Equatorial Guinea in 2007 to that in 2008?
Your answer should be very brief. 0.73. What is the difference between the highest and the second highest Amount(current US$) in Belarus?
Your answer should be compact. 1.07e+1. What is the difference between the highest and the second highest Amount(current US$) of Congo (Democratic)?
Offer a very short reply. 9.00e+08. What is the difference between the highest and the second highest Amount(current US$) in Equatorial Guinea?
Your answer should be very brief. 1.02e+09. What is the difference between the highest and the lowest Amount(current US$) in Belarus?
Your answer should be compact. 3.11e+1. What is the difference between the highest and the lowest Amount(current US$) of Congo (Democratic)?
Your answer should be compact. 3.51e+09. What is the difference between the highest and the lowest Amount(current US$) in Equatorial Guinea?
Ensure brevity in your answer.  3.28e+09. 